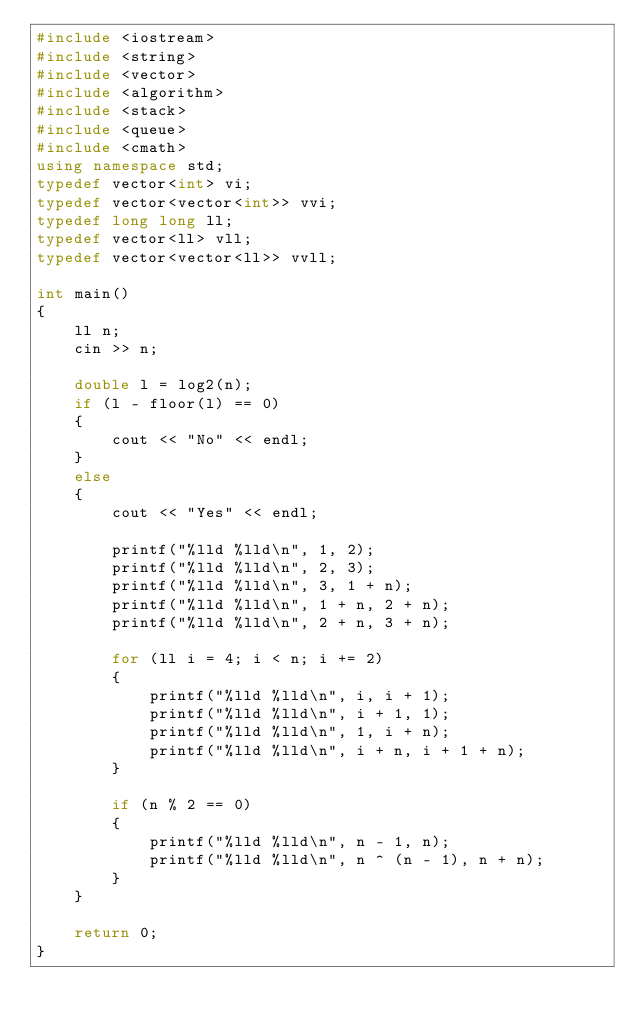Convert code to text. <code><loc_0><loc_0><loc_500><loc_500><_C++_>#include <iostream>
#include <string>
#include <vector>
#include <algorithm>
#include <stack>
#include <queue>
#include <cmath>
using namespace std;
typedef vector<int> vi;
typedef vector<vector<int>> vvi;
typedef long long ll;
typedef vector<ll> vll;
typedef vector<vector<ll>> vvll;

int main()
{
    ll n;
    cin >> n;

    double l = log2(n);
    if (l - floor(l) == 0)
    {
        cout << "No" << endl;
    }
    else
    {
        cout << "Yes" << endl;

        printf("%lld %lld\n", 1, 2);
        printf("%lld %lld\n", 2, 3);
        printf("%lld %lld\n", 3, 1 + n);
        printf("%lld %lld\n", 1 + n, 2 + n);
        printf("%lld %lld\n", 2 + n, 3 + n);

        for (ll i = 4; i < n; i += 2)
        {
            printf("%lld %lld\n", i, i + 1);
            printf("%lld %lld\n", i + 1, 1);
            printf("%lld %lld\n", 1, i + n);
            printf("%lld %lld\n", i + n, i + 1 + n);
        }

        if (n % 2 == 0)
        {
            printf("%lld %lld\n", n - 1, n);
            printf("%lld %lld\n", n ^ (n - 1), n + n);
        }
    }

    return 0;
}
</code> 